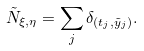Convert formula to latex. <formula><loc_0><loc_0><loc_500><loc_500>\tilde { N } _ { \xi , \eta } = \sum _ { j } \delta _ { ( t _ { j } , \tilde { y } _ { j } ) } .</formula> 